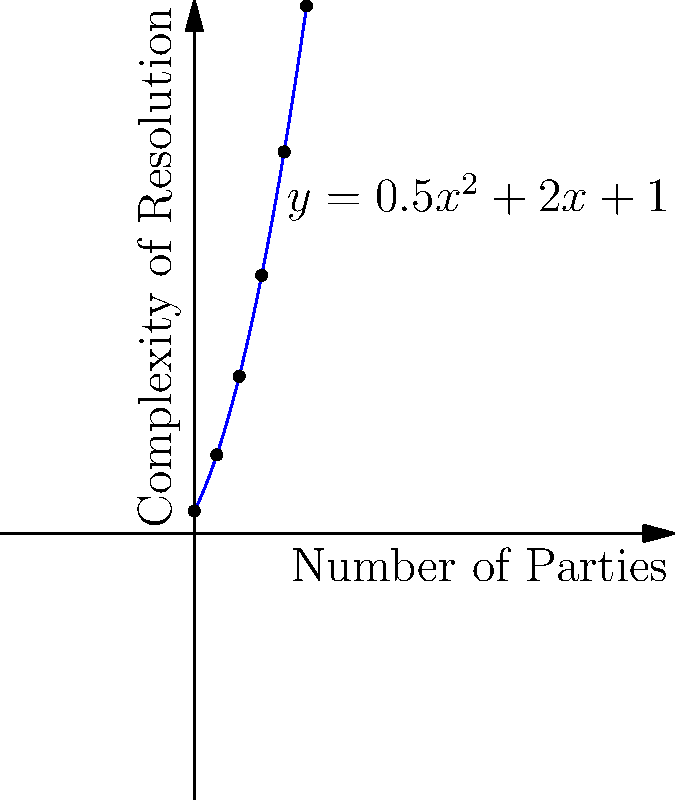The graph shows the relationship between the number of parties involved in a conflict (x-axis) and the complexity of resolution (y-axis), represented by the function $y = 0.5x^2 + 2x + 1$. If a conflict involves 4 parties, what is the corresponding complexity of resolution? To find the complexity of resolution for 4 parties, we need to substitute x = 4 into the given function:

1. Start with the function: $y = 0.5x^2 + 2x + 1$
2. Substitute x = 4: $y = 0.5(4)^2 + 2(4) + 1$
3. Simplify the squared term: $y = 0.5(16) + 2(4) + 1$
4. Multiply: $y = 8 + 8 + 1$
5. Add the terms: $y = 17$

Therefore, when there are 4 parties involved in a conflict, the complexity of resolution is 17 units.
Answer: 17 